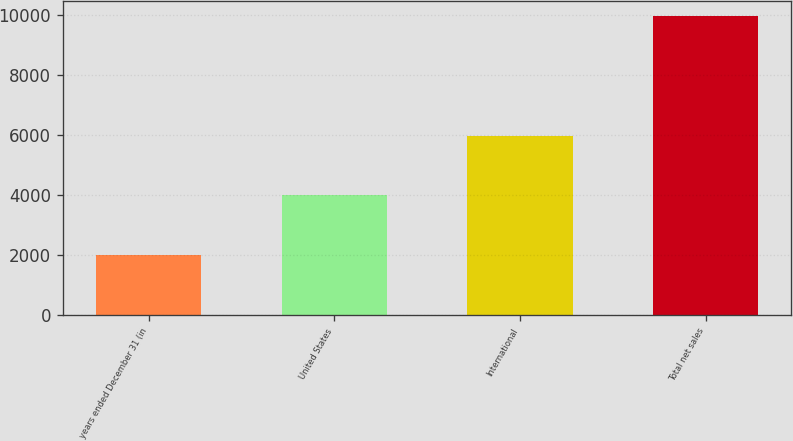Convert chart. <chart><loc_0><loc_0><loc_500><loc_500><bar_chart><fcel>years ended December 31 (in<fcel>United States<fcel>International<fcel>Total net sales<nl><fcel>2015<fcel>4001<fcel>5967<fcel>9968<nl></chart> 